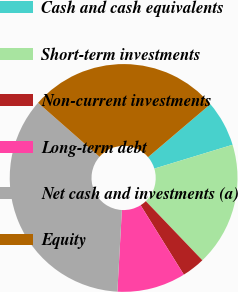Convert chart to OTSL. <chart><loc_0><loc_0><loc_500><loc_500><pie_chart><fcel>Cash and cash equivalents<fcel>Short-term investments<fcel>Non-current investments<fcel>Long-term debt<fcel>Net cash and investments (a)<fcel>Equity<nl><fcel>6.51%<fcel>17.56%<fcel>3.28%<fcel>9.74%<fcel>35.6%<fcel>27.31%<nl></chart> 